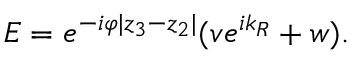Convert formula to latex. <formula><loc_0><loc_0><loc_500><loc_500>E = e ^ { - i \varphi | z _ { 3 } - z _ { 2 } | } ( v e ^ { i k _ { R } } + w ) .</formula> 